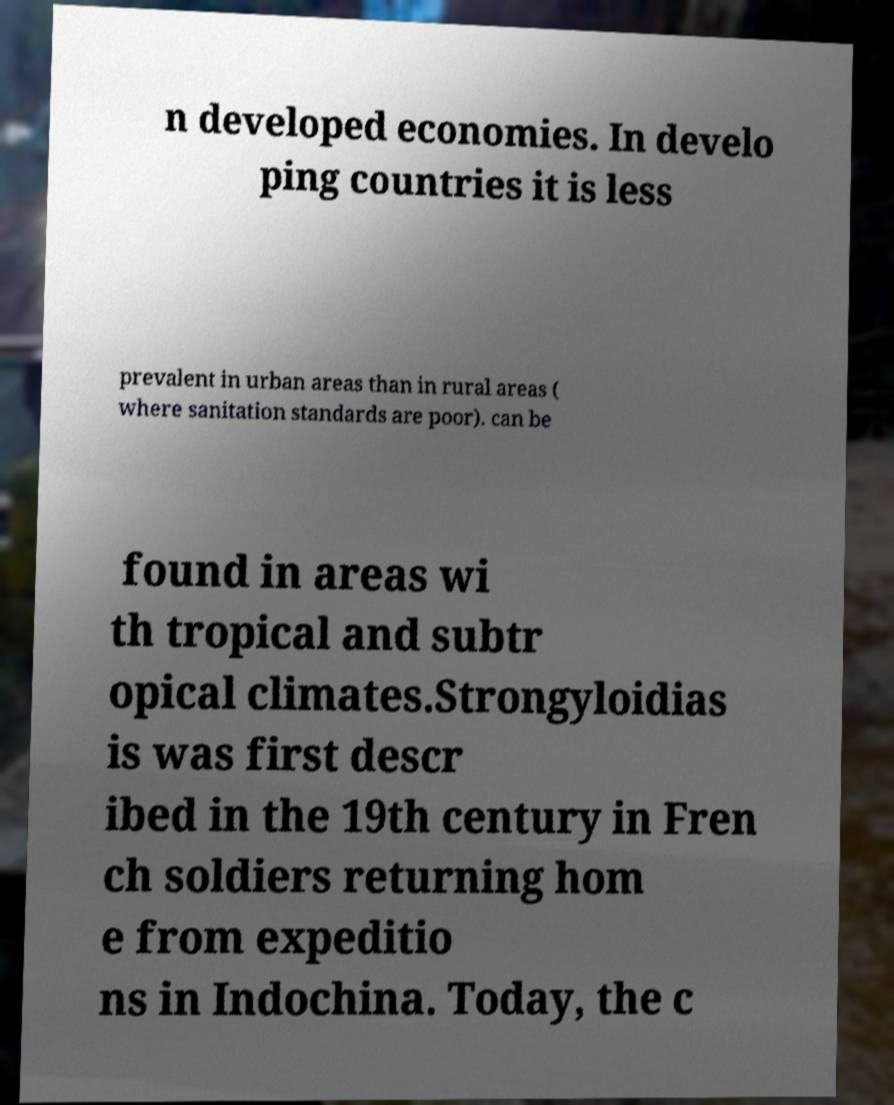Can you accurately transcribe the text from the provided image for me? n developed economies. In develo ping countries it is less prevalent in urban areas than in rural areas ( where sanitation standards are poor). can be found in areas wi th tropical and subtr opical climates.Strongyloidias is was first descr ibed in the 19th century in Fren ch soldiers returning hom e from expeditio ns in Indochina. Today, the c 